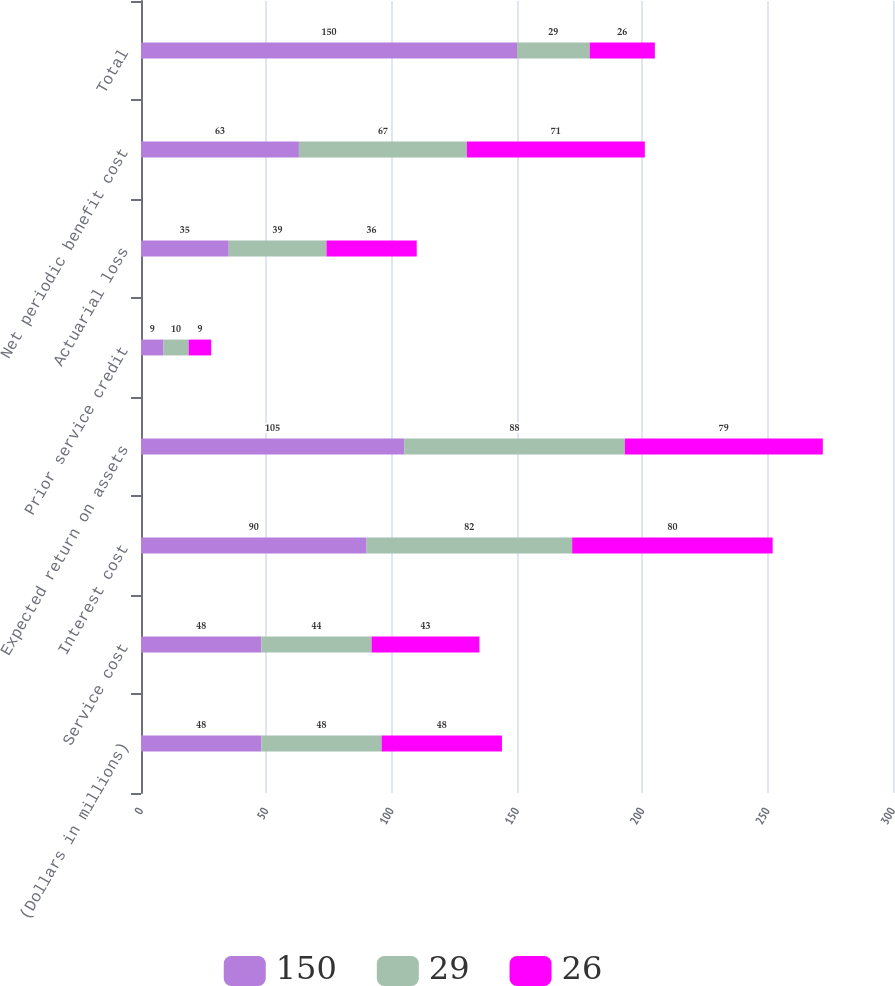<chart> <loc_0><loc_0><loc_500><loc_500><stacked_bar_chart><ecel><fcel>(Dollars in millions)<fcel>Service cost<fcel>Interest cost<fcel>Expected return on assets<fcel>Prior service credit<fcel>Actuarial loss<fcel>Net periodic benefit cost<fcel>Total<nl><fcel>150<fcel>48<fcel>48<fcel>90<fcel>105<fcel>9<fcel>35<fcel>63<fcel>150<nl><fcel>29<fcel>48<fcel>44<fcel>82<fcel>88<fcel>10<fcel>39<fcel>67<fcel>29<nl><fcel>26<fcel>48<fcel>43<fcel>80<fcel>79<fcel>9<fcel>36<fcel>71<fcel>26<nl></chart> 